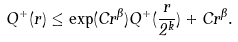<formula> <loc_0><loc_0><loc_500><loc_500>Q ^ { + } ( r ) \leq \exp ( C r ^ { \beta } ) Q ^ { + } ( \frac { r } { 2 ^ { k } } ) + C r ^ { \beta } .</formula> 